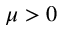Convert formula to latex. <formula><loc_0><loc_0><loc_500><loc_500>\mu > 0</formula> 